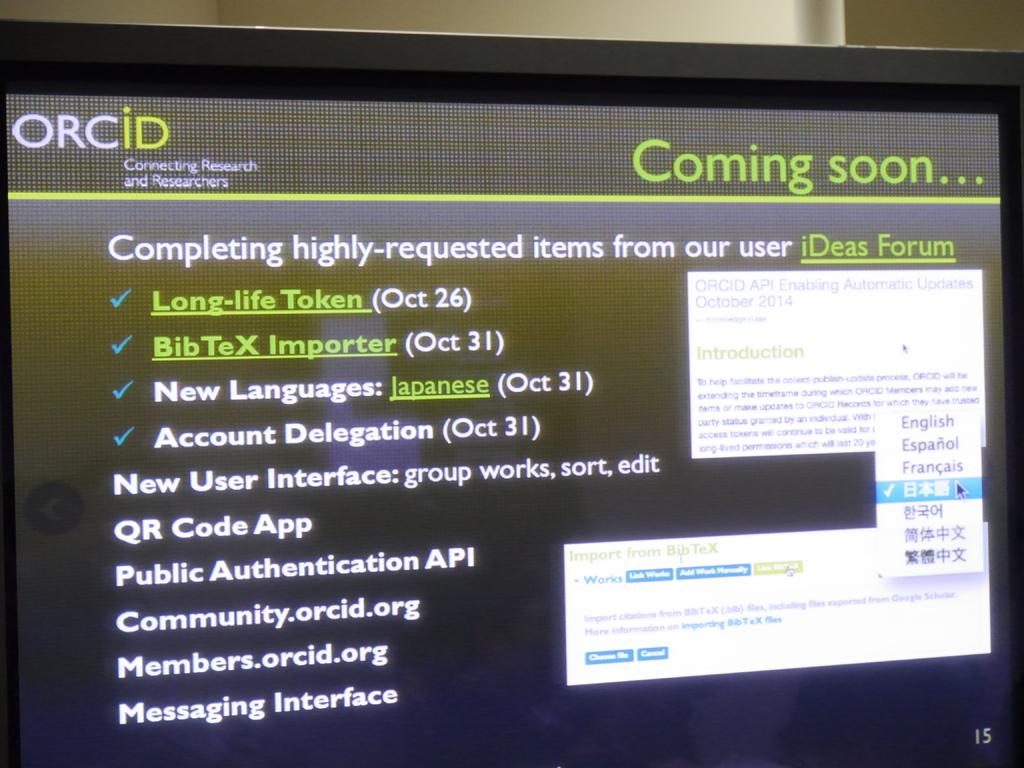Is this coming soon?
Your answer should be very brief. Yes. 